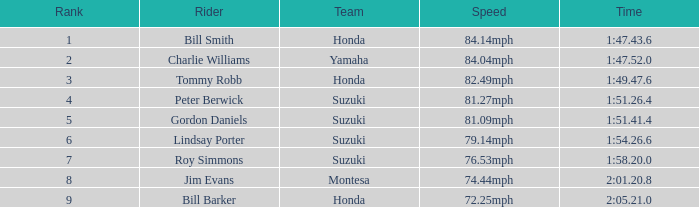What was the timing for peter berwick of team suzuki? 1:51.26.4. 